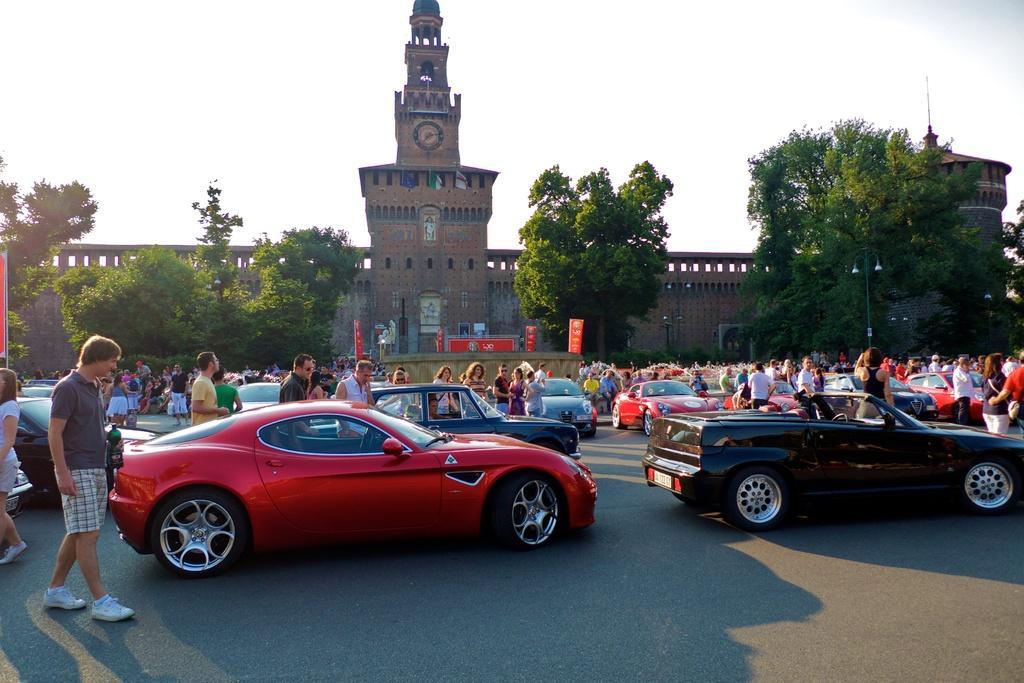How would you summarize this image in a sentence or two? At the bottom of the image we can see cars on the road and there are people. In the background there is a building, trees and sky. 